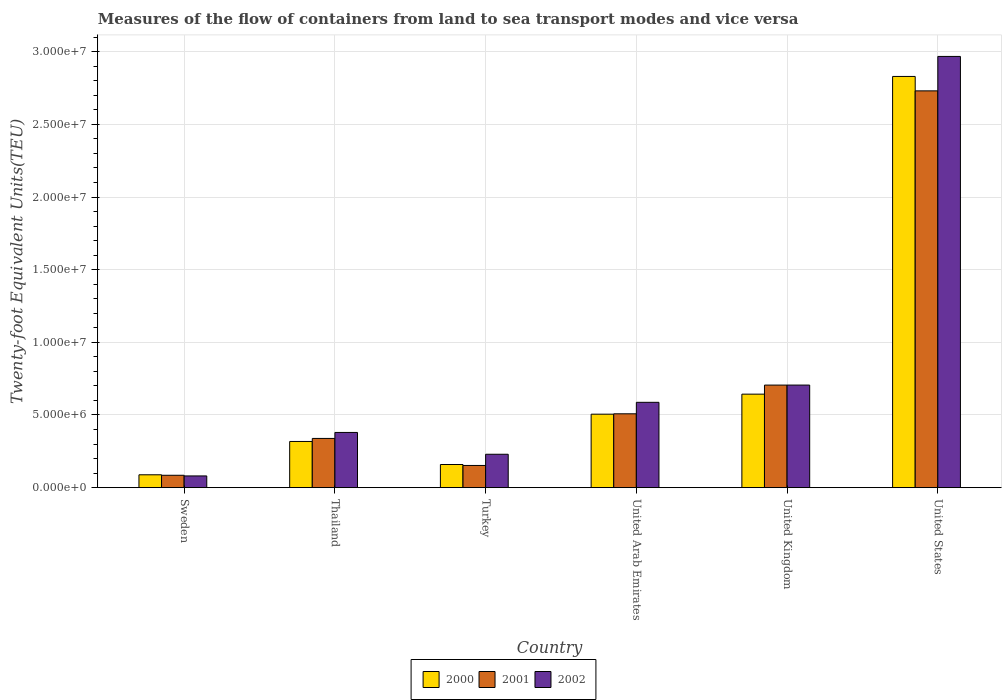How many groups of bars are there?
Your answer should be very brief. 6. Are the number of bars per tick equal to the number of legend labels?
Provide a succinct answer. Yes. Are the number of bars on each tick of the X-axis equal?
Provide a short and direct response. Yes. How many bars are there on the 5th tick from the right?
Give a very brief answer. 3. In how many cases, is the number of bars for a given country not equal to the number of legend labels?
Keep it short and to the point. 0. What is the container port traffic in 2001 in Turkey?
Provide a short and direct response. 1.53e+06. Across all countries, what is the maximum container port traffic in 2001?
Provide a succinct answer. 2.73e+07. Across all countries, what is the minimum container port traffic in 2000?
Keep it short and to the point. 8.84e+05. In which country was the container port traffic in 2002 maximum?
Offer a very short reply. United States. What is the total container port traffic in 2002 in the graph?
Offer a very short reply. 4.95e+07. What is the difference between the container port traffic in 2001 in Sweden and that in United Kingdom?
Provide a succinct answer. -6.21e+06. What is the difference between the container port traffic in 2001 in Thailand and the container port traffic in 2000 in United Arab Emirates?
Your response must be concise. -1.67e+06. What is the average container port traffic in 2001 per country?
Your answer should be very brief. 7.54e+06. What is the difference between the container port traffic of/in 2002 and container port traffic of/in 2000 in Sweden?
Keep it short and to the point. -7.85e+04. What is the ratio of the container port traffic in 2001 in United Arab Emirates to that in United States?
Provide a short and direct response. 0.19. Is the difference between the container port traffic in 2002 in Sweden and United States greater than the difference between the container port traffic in 2000 in Sweden and United States?
Offer a terse response. No. What is the difference between the highest and the second highest container port traffic in 2002?
Ensure brevity in your answer.  -2.38e+07. What is the difference between the highest and the lowest container port traffic in 2001?
Give a very brief answer. 2.65e+07. What does the 3rd bar from the left in United Kingdom represents?
Keep it short and to the point. 2002. How many bars are there?
Provide a short and direct response. 18. Are all the bars in the graph horizontal?
Provide a succinct answer. No. What is the difference between two consecutive major ticks on the Y-axis?
Give a very brief answer. 5.00e+06. Are the values on the major ticks of Y-axis written in scientific E-notation?
Keep it short and to the point. Yes. Does the graph contain grids?
Offer a very short reply. Yes. How many legend labels are there?
Make the answer very short. 3. What is the title of the graph?
Make the answer very short. Measures of the flow of containers from land to sea transport modes and vice versa. What is the label or title of the Y-axis?
Your answer should be very brief. Twenty-foot Equivalent Units(TEU). What is the Twenty-foot Equivalent Units(TEU) in 2000 in Sweden?
Provide a short and direct response. 8.84e+05. What is the Twenty-foot Equivalent Units(TEU) in 2001 in Sweden?
Give a very brief answer. 8.51e+05. What is the Twenty-foot Equivalent Units(TEU) of 2002 in Sweden?
Make the answer very short. 8.06e+05. What is the Twenty-foot Equivalent Units(TEU) of 2000 in Thailand?
Ensure brevity in your answer.  3.18e+06. What is the Twenty-foot Equivalent Units(TEU) of 2001 in Thailand?
Provide a succinct answer. 3.39e+06. What is the Twenty-foot Equivalent Units(TEU) in 2002 in Thailand?
Give a very brief answer. 3.80e+06. What is the Twenty-foot Equivalent Units(TEU) of 2000 in Turkey?
Offer a very short reply. 1.59e+06. What is the Twenty-foot Equivalent Units(TEU) in 2001 in Turkey?
Offer a very short reply. 1.53e+06. What is the Twenty-foot Equivalent Units(TEU) in 2002 in Turkey?
Your answer should be very brief. 2.30e+06. What is the Twenty-foot Equivalent Units(TEU) of 2000 in United Arab Emirates?
Your response must be concise. 5.06e+06. What is the Twenty-foot Equivalent Units(TEU) in 2001 in United Arab Emirates?
Provide a succinct answer. 5.08e+06. What is the Twenty-foot Equivalent Units(TEU) of 2002 in United Arab Emirates?
Offer a terse response. 5.87e+06. What is the Twenty-foot Equivalent Units(TEU) in 2000 in United Kingdom?
Provide a succinct answer. 6.43e+06. What is the Twenty-foot Equivalent Units(TEU) in 2001 in United Kingdom?
Your answer should be compact. 7.06e+06. What is the Twenty-foot Equivalent Units(TEU) of 2002 in United Kingdom?
Ensure brevity in your answer.  7.06e+06. What is the Twenty-foot Equivalent Units(TEU) in 2000 in United States?
Give a very brief answer. 2.83e+07. What is the Twenty-foot Equivalent Units(TEU) in 2001 in United States?
Make the answer very short. 2.73e+07. What is the Twenty-foot Equivalent Units(TEU) in 2002 in United States?
Make the answer very short. 2.97e+07. Across all countries, what is the maximum Twenty-foot Equivalent Units(TEU) in 2000?
Provide a short and direct response. 2.83e+07. Across all countries, what is the maximum Twenty-foot Equivalent Units(TEU) of 2001?
Ensure brevity in your answer.  2.73e+07. Across all countries, what is the maximum Twenty-foot Equivalent Units(TEU) of 2002?
Your answer should be compact. 2.97e+07. Across all countries, what is the minimum Twenty-foot Equivalent Units(TEU) in 2000?
Ensure brevity in your answer.  8.84e+05. Across all countries, what is the minimum Twenty-foot Equivalent Units(TEU) in 2001?
Provide a short and direct response. 8.51e+05. Across all countries, what is the minimum Twenty-foot Equivalent Units(TEU) in 2002?
Give a very brief answer. 8.06e+05. What is the total Twenty-foot Equivalent Units(TEU) in 2000 in the graph?
Ensure brevity in your answer.  4.54e+07. What is the total Twenty-foot Equivalent Units(TEU) of 2001 in the graph?
Provide a succinct answer. 4.52e+07. What is the total Twenty-foot Equivalent Units(TEU) of 2002 in the graph?
Make the answer very short. 4.95e+07. What is the difference between the Twenty-foot Equivalent Units(TEU) of 2000 in Sweden and that in Thailand?
Provide a succinct answer. -2.29e+06. What is the difference between the Twenty-foot Equivalent Units(TEU) of 2001 in Sweden and that in Thailand?
Your answer should be very brief. -2.54e+06. What is the difference between the Twenty-foot Equivalent Units(TEU) in 2002 in Sweden and that in Thailand?
Offer a terse response. -2.99e+06. What is the difference between the Twenty-foot Equivalent Units(TEU) of 2000 in Sweden and that in Turkey?
Your answer should be very brief. -7.08e+05. What is the difference between the Twenty-foot Equivalent Units(TEU) of 2001 in Sweden and that in Turkey?
Give a very brief answer. -6.75e+05. What is the difference between the Twenty-foot Equivalent Units(TEU) in 2002 in Sweden and that in Turkey?
Make the answer very short. -1.49e+06. What is the difference between the Twenty-foot Equivalent Units(TEU) in 2000 in Sweden and that in United Arab Emirates?
Ensure brevity in your answer.  -4.17e+06. What is the difference between the Twenty-foot Equivalent Units(TEU) in 2001 in Sweden and that in United Arab Emirates?
Provide a short and direct response. -4.23e+06. What is the difference between the Twenty-foot Equivalent Units(TEU) of 2002 in Sweden and that in United Arab Emirates?
Provide a succinct answer. -5.07e+06. What is the difference between the Twenty-foot Equivalent Units(TEU) in 2000 in Sweden and that in United Kingdom?
Keep it short and to the point. -5.55e+06. What is the difference between the Twenty-foot Equivalent Units(TEU) in 2001 in Sweden and that in United Kingdom?
Provide a short and direct response. -6.21e+06. What is the difference between the Twenty-foot Equivalent Units(TEU) in 2002 in Sweden and that in United Kingdom?
Offer a terse response. -6.25e+06. What is the difference between the Twenty-foot Equivalent Units(TEU) of 2000 in Sweden and that in United States?
Your response must be concise. -2.74e+07. What is the difference between the Twenty-foot Equivalent Units(TEU) in 2001 in Sweden and that in United States?
Your answer should be very brief. -2.65e+07. What is the difference between the Twenty-foot Equivalent Units(TEU) of 2002 in Sweden and that in United States?
Offer a terse response. -2.89e+07. What is the difference between the Twenty-foot Equivalent Units(TEU) in 2000 in Thailand and that in Turkey?
Make the answer very short. 1.59e+06. What is the difference between the Twenty-foot Equivalent Units(TEU) of 2001 in Thailand and that in Turkey?
Offer a terse response. 1.86e+06. What is the difference between the Twenty-foot Equivalent Units(TEU) in 2002 in Thailand and that in Turkey?
Provide a short and direct response. 1.50e+06. What is the difference between the Twenty-foot Equivalent Units(TEU) of 2000 in Thailand and that in United Arab Emirates?
Give a very brief answer. -1.88e+06. What is the difference between the Twenty-foot Equivalent Units(TEU) of 2001 in Thailand and that in United Arab Emirates?
Ensure brevity in your answer.  -1.69e+06. What is the difference between the Twenty-foot Equivalent Units(TEU) of 2002 in Thailand and that in United Arab Emirates?
Offer a terse response. -2.07e+06. What is the difference between the Twenty-foot Equivalent Units(TEU) in 2000 in Thailand and that in United Kingdom?
Keep it short and to the point. -3.26e+06. What is the difference between the Twenty-foot Equivalent Units(TEU) in 2001 in Thailand and that in United Kingdom?
Offer a very short reply. -3.67e+06. What is the difference between the Twenty-foot Equivalent Units(TEU) in 2002 in Thailand and that in United Kingdom?
Keep it short and to the point. -3.26e+06. What is the difference between the Twenty-foot Equivalent Units(TEU) in 2000 in Thailand and that in United States?
Your response must be concise. -2.51e+07. What is the difference between the Twenty-foot Equivalent Units(TEU) in 2001 in Thailand and that in United States?
Your answer should be very brief. -2.39e+07. What is the difference between the Twenty-foot Equivalent Units(TEU) of 2002 in Thailand and that in United States?
Give a very brief answer. -2.59e+07. What is the difference between the Twenty-foot Equivalent Units(TEU) of 2000 in Turkey and that in United Arab Emirates?
Offer a terse response. -3.46e+06. What is the difference between the Twenty-foot Equivalent Units(TEU) of 2001 in Turkey and that in United Arab Emirates?
Offer a terse response. -3.56e+06. What is the difference between the Twenty-foot Equivalent Units(TEU) of 2002 in Turkey and that in United Arab Emirates?
Offer a very short reply. -3.57e+06. What is the difference between the Twenty-foot Equivalent Units(TEU) in 2000 in Turkey and that in United Kingdom?
Offer a terse response. -4.84e+06. What is the difference between the Twenty-foot Equivalent Units(TEU) of 2001 in Turkey and that in United Kingdom?
Provide a short and direct response. -5.53e+06. What is the difference between the Twenty-foot Equivalent Units(TEU) in 2002 in Turkey and that in United Kingdom?
Provide a succinct answer. -4.76e+06. What is the difference between the Twenty-foot Equivalent Units(TEU) of 2000 in Turkey and that in United States?
Provide a short and direct response. -2.67e+07. What is the difference between the Twenty-foot Equivalent Units(TEU) of 2001 in Turkey and that in United States?
Offer a very short reply. -2.58e+07. What is the difference between the Twenty-foot Equivalent Units(TEU) in 2002 in Turkey and that in United States?
Your answer should be very brief. -2.74e+07. What is the difference between the Twenty-foot Equivalent Units(TEU) in 2000 in United Arab Emirates and that in United Kingdom?
Give a very brief answer. -1.38e+06. What is the difference between the Twenty-foot Equivalent Units(TEU) in 2001 in United Arab Emirates and that in United Kingdom?
Your response must be concise. -1.98e+06. What is the difference between the Twenty-foot Equivalent Units(TEU) of 2002 in United Arab Emirates and that in United Kingdom?
Ensure brevity in your answer.  -1.19e+06. What is the difference between the Twenty-foot Equivalent Units(TEU) of 2000 in United Arab Emirates and that in United States?
Provide a short and direct response. -2.32e+07. What is the difference between the Twenty-foot Equivalent Units(TEU) in 2001 in United Arab Emirates and that in United States?
Ensure brevity in your answer.  -2.22e+07. What is the difference between the Twenty-foot Equivalent Units(TEU) of 2002 in United Arab Emirates and that in United States?
Give a very brief answer. -2.38e+07. What is the difference between the Twenty-foot Equivalent Units(TEU) in 2000 in United Kingdom and that in United States?
Provide a short and direct response. -2.19e+07. What is the difference between the Twenty-foot Equivalent Units(TEU) in 2001 in United Kingdom and that in United States?
Your response must be concise. -2.02e+07. What is the difference between the Twenty-foot Equivalent Units(TEU) of 2002 in United Kingdom and that in United States?
Keep it short and to the point. -2.26e+07. What is the difference between the Twenty-foot Equivalent Units(TEU) of 2000 in Sweden and the Twenty-foot Equivalent Units(TEU) of 2001 in Thailand?
Offer a very short reply. -2.50e+06. What is the difference between the Twenty-foot Equivalent Units(TEU) in 2000 in Sweden and the Twenty-foot Equivalent Units(TEU) in 2002 in Thailand?
Offer a very short reply. -2.91e+06. What is the difference between the Twenty-foot Equivalent Units(TEU) in 2001 in Sweden and the Twenty-foot Equivalent Units(TEU) in 2002 in Thailand?
Your answer should be very brief. -2.95e+06. What is the difference between the Twenty-foot Equivalent Units(TEU) in 2000 in Sweden and the Twenty-foot Equivalent Units(TEU) in 2001 in Turkey?
Your response must be concise. -6.42e+05. What is the difference between the Twenty-foot Equivalent Units(TEU) in 2000 in Sweden and the Twenty-foot Equivalent Units(TEU) in 2002 in Turkey?
Keep it short and to the point. -1.41e+06. What is the difference between the Twenty-foot Equivalent Units(TEU) in 2001 in Sweden and the Twenty-foot Equivalent Units(TEU) in 2002 in Turkey?
Provide a succinct answer. -1.45e+06. What is the difference between the Twenty-foot Equivalent Units(TEU) in 2000 in Sweden and the Twenty-foot Equivalent Units(TEU) in 2001 in United Arab Emirates?
Provide a succinct answer. -4.20e+06. What is the difference between the Twenty-foot Equivalent Units(TEU) of 2000 in Sweden and the Twenty-foot Equivalent Units(TEU) of 2002 in United Arab Emirates?
Keep it short and to the point. -4.99e+06. What is the difference between the Twenty-foot Equivalent Units(TEU) in 2001 in Sweden and the Twenty-foot Equivalent Units(TEU) in 2002 in United Arab Emirates?
Provide a short and direct response. -5.02e+06. What is the difference between the Twenty-foot Equivalent Units(TEU) of 2000 in Sweden and the Twenty-foot Equivalent Units(TEU) of 2001 in United Kingdom?
Ensure brevity in your answer.  -6.17e+06. What is the difference between the Twenty-foot Equivalent Units(TEU) of 2000 in Sweden and the Twenty-foot Equivalent Units(TEU) of 2002 in United Kingdom?
Offer a very short reply. -6.18e+06. What is the difference between the Twenty-foot Equivalent Units(TEU) of 2001 in Sweden and the Twenty-foot Equivalent Units(TEU) of 2002 in United Kingdom?
Offer a terse response. -6.21e+06. What is the difference between the Twenty-foot Equivalent Units(TEU) in 2000 in Sweden and the Twenty-foot Equivalent Units(TEU) in 2001 in United States?
Your answer should be compact. -2.64e+07. What is the difference between the Twenty-foot Equivalent Units(TEU) in 2000 in Sweden and the Twenty-foot Equivalent Units(TEU) in 2002 in United States?
Offer a terse response. -2.88e+07. What is the difference between the Twenty-foot Equivalent Units(TEU) of 2001 in Sweden and the Twenty-foot Equivalent Units(TEU) of 2002 in United States?
Give a very brief answer. -2.88e+07. What is the difference between the Twenty-foot Equivalent Units(TEU) in 2000 in Thailand and the Twenty-foot Equivalent Units(TEU) in 2001 in Turkey?
Ensure brevity in your answer.  1.65e+06. What is the difference between the Twenty-foot Equivalent Units(TEU) in 2000 in Thailand and the Twenty-foot Equivalent Units(TEU) in 2002 in Turkey?
Offer a very short reply. 8.81e+05. What is the difference between the Twenty-foot Equivalent Units(TEU) in 2001 in Thailand and the Twenty-foot Equivalent Units(TEU) in 2002 in Turkey?
Give a very brief answer. 1.09e+06. What is the difference between the Twenty-foot Equivalent Units(TEU) in 2000 in Thailand and the Twenty-foot Equivalent Units(TEU) in 2001 in United Arab Emirates?
Your response must be concise. -1.90e+06. What is the difference between the Twenty-foot Equivalent Units(TEU) of 2000 in Thailand and the Twenty-foot Equivalent Units(TEU) of 2002 in United Arab Emirates?
Keep it short and to the point. -2.69e+06. What is the difference between the Twenty-foot Equivalent Units(TEU) of 2001 in Thailand and the Twenty-foot Equivalent Units(TEU) of 2002 in United Arab Emirates?
Provide a short and direct response. -2.49e+06. What is the difference between the Twenty-foot Equivalent Units(TEU) in 2000 in Thailand and the Twenty-foot Equivalent Units(TEU) in 2001 in United Kingdom?
Offer a very short reply. -3.88e+06. What is the difference between the Twenty-foot Equivalent Units(TEU) in 2000 in Thailand and the Twenty-foot Equivalent Units(TEU) in 2002 in United Kingdom?
Ensure brevity in your answer.  -3.88e+06. What is the difference between the Twenty-foot Equivalent Units(TEU) in 2001 in Thailand and the Twenty-foot Equivalent Units(TEU) in 2002 in United Kingdom?
Ensure brevity in your answer.  -3.67e+06. What is the difference between the Twenty-foot Equivalent Units(TEU) in 2000 in Thailand and the Twenty-foot Equivalent Units(TEU) in 2001 in United States?
Your answer should be compact. -2.41e+07. What is the difference between the Twenty-foot Equivalent Units(TEU) in 2000 in Thailand and the Twenty-foot Equivalent Units(TEU) in 2002 in United States?
Make the answer very short. -2.65e+07. What is the difference between the Twenty-foot Equivalent Units(TEU) of 2001 in Thailand and the Twenty-foot Equivalent Units(TEU) of 2002 in United States?
Your answer should be compact. -2.63e+07. What is the difference between the Twenty-foot Equivalent Units(TEU) of 2000 in Turkey and the Twenty-foot Equivalent Units(TEU) of 2001 in United Arab Emirates?
Your response must be concise. -3.49e+06. What is the difference between the Twenty-foot Equivalent Units(TEU) of 2000 in Turkey and the Twenty-foot Equivalent Units(TEU) of 2002 in United Arab Emirates?
Make the answer very short. -4.28e+06. What is the difference between the Twenty-foot Equivalent Units(TEU) in 2001 in Turkey and the Twenty-foot Equivalent Units(TEU) in 2002 in United Arab Emirates?
Offer a terse response. -4.35e+06. What is the difference between the Twenty-foot Equivalent Units(TEU) in 2000 in Turkey and the Twenty-foot Equivalent Units(TEU) in 2001 in United Kingdom?
Your answer should be very brief. -5.47e+06. What is the difference between the Twenty-foot Equivalent Units(TEU) of 2000 in Turkey and the Twenty-foot Equivalent Units(TEU) of 2002 in United Kingdom?
Your answer should be very brief. -5.47e+06. What is the difference between the Twenty-foot Equivalent Units(TEU) of 2001 in Turkey and the Twenty-foot Equivalent Units(TEU) of 2002 in United Kingdom?
Your answer should be very brief. -5.53e+06. What is the difference between the Twenty-foot Equivalent Units(TEU) in 2000 in Turkey and the Twenty-foot Equivalent Units(TEU) in 2001 in United States?
Give a very brief answer. -2.57e+07. What is the difference between the Twenty-foot Equivalent Units(TEU) of 2000 in Turkey and the Twenty-foot Equivalent Units(TEU) of 2002 in United States?
Ensure brevity in your answer.  -2.81e+07. What is the difference between the Twenty-foot Equivalent Units(TEU) in 2001 in Turkey and the Twenty-foot Equivalent Units(TEU) in 2002 in United States?
Make the answer very short. -2.82e+07. What is the difference between the Twenty-foot Equivalent Units(TEU) of 2000 in United Arab Emirates and the Twenty-foot Equivalent Units(TEU) of 2001 in United Kingdom?
Your response must be concise. -2.00e+06. What is the difference between the Twenty-foot Equivalent Units(TEU) in 2000 in United Arab Emirates and the Twenty-foot Equivalent Units(TEU) in 2002 in United Kingdom?
Your answer should be very brief. -2.00e+06. What is the difference between the Twenty-foot Equivalent Units(TEU) in 2001 in United Arab Emirates and the Twenty-foot Equivalent Units(TEU) in 2002 in United Kingdom?
Your answer should be compact. -1.98e+06. What is the difference between the Twenty-foot Equivalent Units(TEU) in 2000 in United Arab Emirates and the Twenty-foot Equivalent Units(TEU) in 2001 in United States?
Give a very brief answer. -2.23e+07. What is the difference between the Twenty-foot Equivalent Units(TEU) of 2000 in United Arab Emirates and the Twenty-foot Equivalent Units(TEU) of 2002 in United States?
Offer a very short reply. -2.46e+07. What is the difference between the Twenty-foot Equivalent Units(TEU) of 2001 in United Arab Emirates and the Twenty-foot Equivalent Units(TEU) of 2002 in United States?
Offer a very short reply. -2.46e+07. What is the difference between the Twenty-foot Equivalent Units(TEU) in 2000 in United Kingdom and the Twenty-foot Equivalent Units(TEU) in 2001 in United States?
Make the answer very short. -2.09e+07. What is the difference between the Twenty-foot Equivalent Units(TEU) of 2000 in United Kingdom and the Twenty-foot Equivalent Units(TEU) of 2002 in United States?
Provide a succinct answer. -2.32e+07. What is the difference between the Twenty-foot Equivalent Units(TEU) in 2001 in United Kingdom and the Twenty-foot Equivalent Units(TEU) in 2002 in United States?
Your answer should be compact. -2.26e+07. What is the average Twenty-foot Equivalent Units(TEU) of 2000 per country?
Your response must be concise. 7.57e+06. What is the average Twenty-foot Equivalent Units(TEU) of 2001 per country?
Ensure brevity in your answer.  7.54e+06. What is the average Twenty-foot Equivalent Units(TEU) of 2002 per country?
Give a very brief answer. 8.25e+06. What is the difference between the Twenty-foot Equivalent Units(TEU) in 2000 and Twenty-foot Equivalent Units(TEU) in 2001 in Sweden?
Provide a short and direct response. 3.29e+04. What is the difference between the Twenty-foot Equivalent Units(TEU) of 2000 and Twenty-foot Equivalent Units(TEU) of 2002 in Sweden?
Keep it short and to the point. 7.85e+04. What is the difference between the Twenty-foot Equivalent Units(TEU) of 2001 and Twenty-foot Equivalent Units(TEU) of 2002 in Sweden?
Ensure brevity in your answer.  4.56e+04. What is the difference between the Twenty-foot Equivalent Units(TEU) in 2000 and Twenty-foot Equivalent Units(TEU) in 2001 in Thailand?
Give a very brief answer. -2.08e+05. What is the difference between the Twenty-foot Equivalent Units(TEU) of 2000 and Twenty-foot Equivalent Units(TEU) of 2002 in Thailand?
Provide a short and direct response. -6.20e+05. What is the difference between the Twenty-foot Equivalent Units(TEU) of 2001 and Twenty-foot Equivalent Units(TEU) of 2002 in Thailand?
Make the answer very short. -4.12e+05. What is the difference between the Twenty-foot Equivalent Units(TEU) in 2000 and Twenty-foot Equivalent Units(TEU) in 2001 in Turkey?
Your answer should be compact. 6.52e+04. What is the difference between the Twenty-foot Equivalent Units(TEU) in 2000 and Twenty-foot Equivalent Units(TEU) in 2002 in Turkey?
Keep it short and to the point. -7.06e+05. What is the difference between the Twenty-foot Equivalent Units(TEU) in 2001 and Twenty-foot Equivalent Units(TEU) in 2002 in Turkey?
Provide a short and direct response. -7.71e+05. What is the difference between the Twenty-foot Equivalent Units(TEU) of 2000 and Twenty-foot Equivalent Units(TEU) of 2001 in United Arab Emirates?
Keep it short and to the point. -2.62e+04. What is the difference between the Twenty-foot Equivalent Units(TEU) of 2000 and Twenty-foot Equivalent Units(TEU) of 2002 in United Arab Emirates?
Your answer should be very brief. -8.16e+05. What is the difference between the Twenty-foot Equivalent Units(TEU) of 2001 and Twenty-foot Equivalent Units(TEU) of 2002 in United Arab Emirates?
Give a very brief answer. -7.90e+05. What is the difference between the Twenty-foot Equivalent Units(TEU) in 2000 and Twenty-foot Equivalent Units(TEU) in 2001 in United Kingdom?
Your answer should be compact. -6.23e+05. What is the difference between the Twenty-foot Equivalent Units(TEU) in 2000 and Twenty-foot Equivalent Units(TEU) in 2002 in United Kingdom?
Give a very brief answer. -6.25e+05. What is the difference between the Twenty-foot Equivalent Units(TEU) in 2001 and Twenty-foot Equivalent Units(TEU) in 2002 in United Kingdom?
Ensure brevity in your answer.  -1556. What is the difference between the Twenty-foot Equivalent Units(TEU) of 2000 and Twenty-foot Equivalent Units(TEU) of 2001 in United States?
Make the answer very short. 9.92e+05. What is the difference between the Twenty-foot Equivalent Units(TEU) of 2000 and Twenty-foot Equivalent Units(TEU) of 2002 in United States?
Offer a very short reply. -1.38e+06. What is the difference between the Twenty-foot Equivalent Units(TEU) in 2001 and Twenty-foot Equivalent Units(TEU) in 2002 in United States?
Offer a terse response. -2.37e+06. What is the ratio of the Twenty-foot Equivalent Units(TEU) in 2000 in Sweden to that in Thailand?
Provide a short and direct response. 0.28. What is the ratio of the Twenty-foot Equivalent Units(TEU) in 2001 in Sweden to that in Thailand?
Your answer should be very brief. 0.25. What is the ratio of the Twenty-foot Equivalent Units(TEU) in 2002 in Sweden to that in Thailand?
Your answer should be compact. 0.21. What is the ratio of the Twenty-foot Equivalent Units(TEU) of 2000 in Sweden to that in Turkey?
Make the answer very short. 0.56. What is the ratio of the Twenty-foot Equivalent Units(TEU) of 2001 in Sweden to that in Turkey?
Make the answer very short. 0.56. What is the ratio of the Twenty-foot Equivalent Units(TEU) of 2002 in Sweden to that in Turkey?
Offer a very short reply. 0.35. What is the ratio of the Twenty-foot Equivalent Units(TEU) in 2000 in Sweden to that in United Arab Emirates?
Keep it short and to the point. 0.17. What is the ratio of the Twenty-foot Equivalent Units(TEU) of 2001 in Sweden to that in United Arab Emirates?
Your answer should be very brief. 0.17. What is the ratio of the Twenty-foot Equivalent Units(TEU) of 2002 in Sweden to that in United Arab Emirates?
Offer a terse response. 0.14. What is the ratio of the Twenty-foot Equivalent Units(TEU) in 2000 in Sweden to that in United Kingdom?
Offer a terse response. 0.14. What is the ratio of the Twenty-foot Equivalent Units(TEU) of 2001 in Sweden to that in United Kingdom?
Your answer should be very brief. 0.12. What is the ratio of the Twenty-foot Equivalent Units(TEU) in 2002 in Sweden to that in United Kingdom?
Your response must be concise. 0.11. What is the ratio of the Twenty-foot Equivalent Units(TEU) of 2000 in Sweden to that in United States?
Offer a very short reply. 0.03. What is the ratio of the Twenty-foot Equivalent Units(TEU) in 2001 in Sweden to that in United States?
Offer a very short reply. 0.03. What is the ratio of the Twenty-foot Equivalent Units(TEU) of 2002 in Sweden to that in United States?
Your answer should be compact. 0.03. What is the ratio of the Twenty-foot Equivalent Units(TEU) of 2000 in Thailand to that in Turkey?
Your answer should be very brief. 2. What is the ratio of the Twenty-foot Equivalent Units(TEU) in 2001 in Thailand to that in Turkey?
Give a very brief answer. 2.22. What is the ratio of the Twenty-foot Equivalent Units(TEU) of 2002 in Thailand to that in Turkey?
Your answer should be compact. 1.65. What is the ratio of the Twenty-foot Equivalent Units(TEU) in 2000 in Thailand to that in United Arab Emirates?
Give a very brief answer. 0.63. What is the ratio of the Twenty-foot Equivalent Units(TEU) of 2001 in Thailand to that in United Arab Emirates?
Your answer should be compact. 0.67. What is the ratio of the Twenty-foot Equivalent Units(TEU) of 2002 in Thailand to that in United Arab Emirates?
Provide a succinct answer. 0.65. What is the ratio of the Twenty-foot Equivalent Units(TEU) in 2000 in Thailand to that in United Kingdom?
Provide a succinct answer. 0.49. What is the ratio of the Twenty-foot Equivalent Units(TEU) in 2001 in Thailand to that in United Kingdom?
Your answer should be very brief. 0.48. What is the ratio of the Twenty-foot Equivalent Units(TEU) in 2002 in Thailand to that in United Kingdom?
Your answer should be compact. 0.54. What is the ratio of the Twenty-foot Equivalent Units(TEU) of 2000 in Thailand to that in United States?
Your answer should be compact. 0.11. What is the ratio of the Twenty-foot Equivalent Units(TEU) in 2001 in Thailand to that in United States?
Your response must be concise. 0.12. What is the ratio of the Twenty-foot Equivalent Units(TEU) in 2002 in Thailand to that in United States?
Keep it short and to the point. 0.13. What is the ratio of the Twenty-foot Equivalent Units(TEU) in 2000 in Turkey to that in United Arab Emirates?
Ensure brevity in your answer.  0.31. What is the ratio of the Twenty-foot Equivalent Units(TEU) in 2001 in Turkey to that in United Arab Emirates?
Your answer should be compact. 0.3. What is the ratio of the Twenty-foot Equivalent Units(TEU) of 2002 in Turkey to that in United Arab Emirates?
Your answer should be compact. 0.39. What is the ratio of the Twenty-foot Equivalent Units(TEU) of 2000 in Turkey to that in United Kingdom?
Your answer should be very brief. 0.25. What is the ratio of the Twenty-foot Equivalent Units(TEU) of 2001 in Turkey to that in United Kingdom?
Offer a very short reply. 0.22. What is the ratio of the Twenty-foot Equivalent Units(TEU) of 2002 in Turkey to that in United Kingdom?
Offer a terse response. 0.33. What is the ratio of the Twenty-foot Equivalent Units(TEU) of 2000 in Turkey to that in United States?
Make the answer very short. 0.06. What is the ratio of the Twenty-foot Equivalent Units(TEU) of 2001 in Turkey to that in United States?
Ensure brevity in your answer.  0.06. What is the ratio of the Twenty-foot Equivalent Units(TEU) in 2002 in Turkey to that in United States?
Offer a very short reply. 0.08. What is the ratio of the Twenty-foot Equivalent Units(TEU) of 2000 in United Arab Emirates to that in United Kingdom?
Your answer should be compact. 0.79. What is the ratio of the Twenty-foot Equivalent Units(TEU) of 2001 in United Arab Emirates to that in United Kingdom?
Keep it short and to the point. 0.72. What is the ratio of the Twenty-foot Equivalent Units(TEU) of 2002 in United Arab Emirates to that in United Kingdom?
Ensure brevity in your answer.  0.83. What is the ratio of the Twenty-foot Equivalent Units(TEU) in 2000 in United Arab Emirates to that in United States?
Make the answer very short. 0.18. What is the ratio of the Twenty-foot Equivalent Units(TEU) of 2001 in United Arab Emirates to that in United States?
Keep it short and to the point. 0.19. What is the ratio of the Twenty-foot Equivalent Units(TEU) of 2002 in United Arab Emirates to that in United States?
Offer a very short reply. 0.2. What is the ratio of the Twenty-foot Equivalent Units(TEU) of 2000 in United Kingdom to that in United States?
Make the answer very short. 0.23. What is the ratio of the Twenty-foot Equivalent Units(TEU) in 2001 in United Kingdom to that in United States?
Provide a succinct answer. 0.26. What is the ratio of the Twenty-foot Equivalent Units(TEU) of 2002 in United Kingdom to that in United States?
Give a very brief answer. 0.24. What is the difference between the highest and the second highest Twenty-foot Equivalent Units(TEU) of 2000?
Ensure brevity in your answer.  2.19e+07. What is the difference between the highest and the second highest Twenty-foot Equivalent Units(TEU) of 2001?
Your answer should be compact. 2.02e+07. What is the difference between the highest and the second highest Twenty-foot Equivalent Units(TEU) of 2002?
Your response must be concise. 2.26e+07. What is the difference between the highest and the lowest Twenty-foot Equivalent Units(TEU) in 2000?
Give a very brief answer. 2.74e+07. What is the difference between the highest and the lowest Twenty-foot Equivalent Units(TEU) of 2001?
Make the answer very short. 2.65e+07. What is the difference between the highest and the lowest Twenty-foot Equivalent Units(TEU) in 2002?
Your response must be concise. 2.89e+07. 